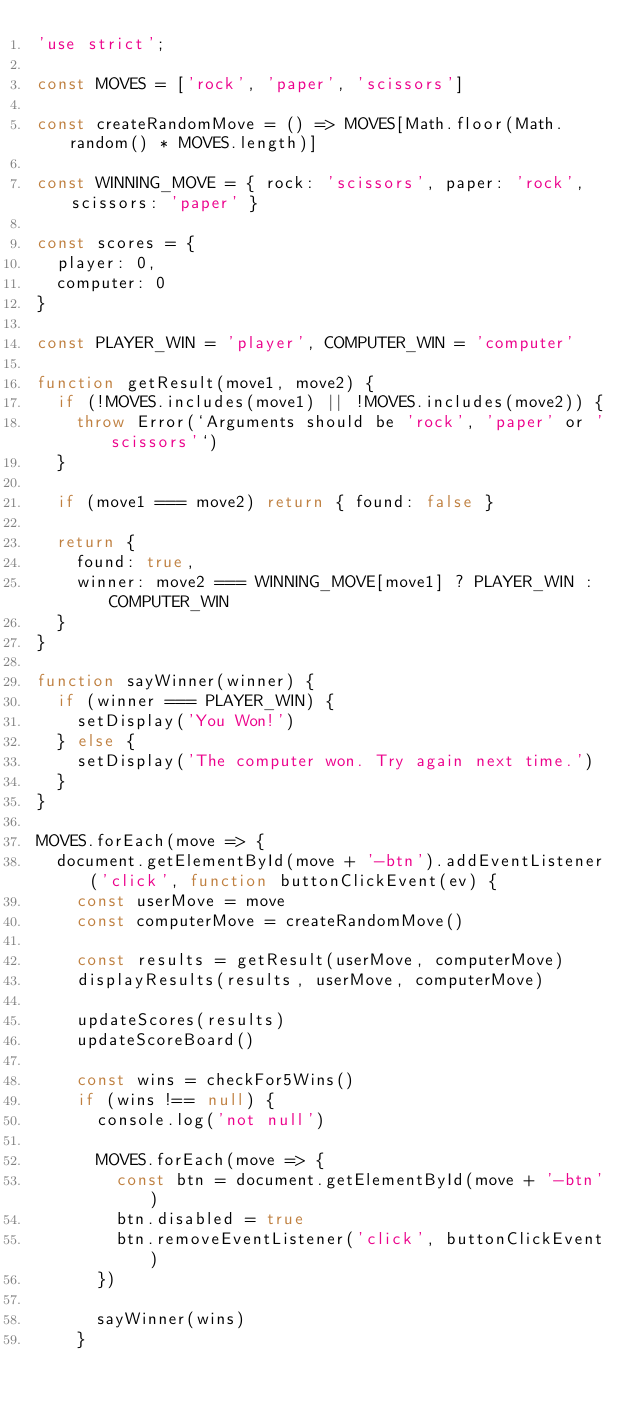Convert code to text. <code><loc_0><loc_0><loc_500><loc_500><_JavaScript_>'use strict';

const MOVES = ['rock', 'paper', 'scissors']

const createRandomMove = () => MOVES[Math.floor(Math.random() * MOVES.length)]

const WINNING_MOVE = { rock: 'scissors', paper: 'rock', scissors: 'paper' }

const scores = {
  player: 0,
  computer: 0
}

const PLAYER_WIN = 'player', COMPUTER_WIN = 'computer'

function getResult(move1, move2) {
  if (!MOVES.includes(move1) || !MOVES.includes(move2)) {
    throw Error(`Arguments should be 'rock', 'paper' or 'scissors'`)
  }

  if (move1 === move2) return { found: false }

  return {
    found: true,
    winner: move2 === WINNING_MOVE[move1] ? PLAYER_WIN : COMPUTER_WIN
  }
}

function sayWinner(winner) {
  if (winner === PLAYER_WIN) {
    setDisplay('You Won!')
  } else {
    setDisplay('The computer won. Try again next time.')
  }
}

MOVES.forEach(move => {
  document.getElementById(move + '-btn').addEventListener('click', function buttonClickEvent(ev) {
    const userMove = move
    const computerMove = createRandomMove()
  
    const results = getResult(userMove, computerMove)
    displayResults(results, userMove, computerMove)
  
    updateScores(results)
    updateScoreBoard()
  
    const wins = checkFor5Wins()
    if (wins !== null) {
      console.log('not null')
  
      MOVES.forEach(move => {
        const btn = document.getElementById(move + '-btn')
        btn.disabled = true
        btn.removeEventListener('click', buttonClickEvent)
      })

      sayWinner(wins)
    }</code> 